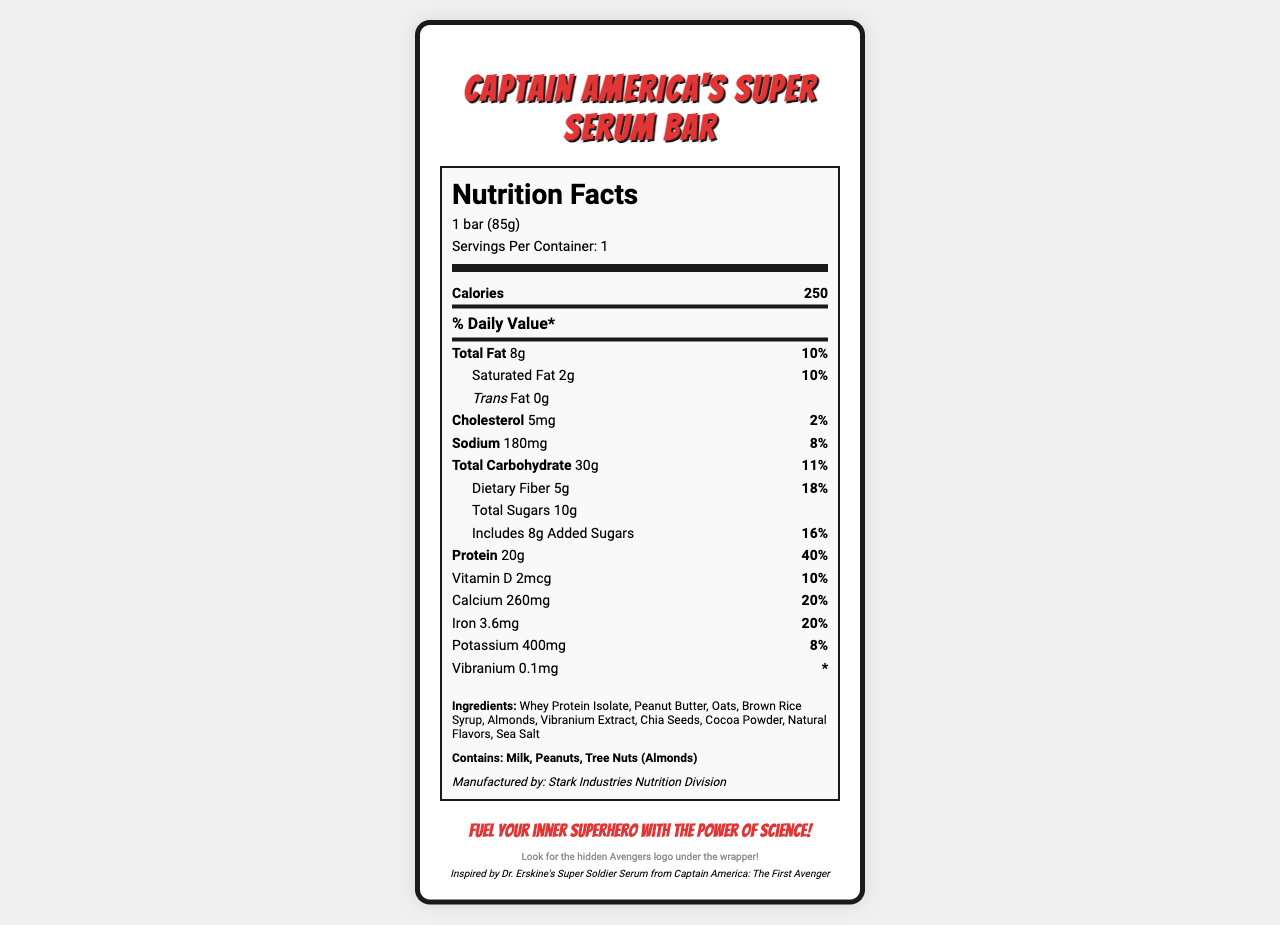what is the serving size of the Captain America's Super Serum Bar? The serving size is clearly listed at the top of the Nutrition Facts under the serving information.
Answer: 1 bar (85g) how much protein does the bar contain? The amount of protein is listed under the "Protein" section of the Nutrition Facts.
Answer: 20g what percentage of the daily value for calcium does this bar provide? The percentage of daily value for calcium is listed under the "Calcium" section of the Nutrition Facts.
Answer: 20% list the allergens mentioned in the bar. The allergen information is explicitly stated at the bottom of the Nutrition Facts section.
Answer: Milk, Peanuts, Tree Nuts (Almonds) what unique ingredient is included in the bar? The unique ingredient, Vibranium Extract, is listed in the ingredients section.
Answer: Vibranium Extract how many calories does one bar provide? The number of calories is listed at the top of the Nutrition Facts.
Answer: 250 which company manufactures this bar? The manufacturer information is listed at the bottom of the Nutrition Facts section.
Answer: Stark Industries Nutrition Division what superhero is referenced as inspiration for this protein bar? The reference to "Captain America: The First Avenger" is mentioned at the bottom in the movie reference section.
Answer: Captain America what is the fat content of the bar? 
A. 6g 
B. 8g
C. 12g 
D. 2g The total fat content is listed as 8g in the Nutrition Facts section.
Answer: B how much dietary fiber is in the Captain America's Super Serum Bar?
i. 10g
ii. 5g
iii. 2g The dietary fiber content is listed as 5g in the Nutrition Facts section.
Answer: ii is there any trans fat in the bar? The trans fat content is listed as 0g.
Answer: No summarize the main features of Captain America's Super Serum Bar. This summary captures the primary details and features of the protein bar, including nutritional information, unique ingredients, and inspirational background.
Answer: The Captain America's Super Serum Bar contains 250 calories per serving, 20g of protein, and a unique ingredient called Vibranium Extract. Produced by Stark Industries Nutrition Division, it offers significant amounts of daily vitamins and minerals and is inspired by the Super Soldier Serum from Captain America: The First Avenger. It also contains allergens like milk, peanuts, and tree nuts. how much weight will you gain after consuming the bar? The document provides nutrition and ingredient details but does not offer information on weight gain.
Answer: Not enough information 